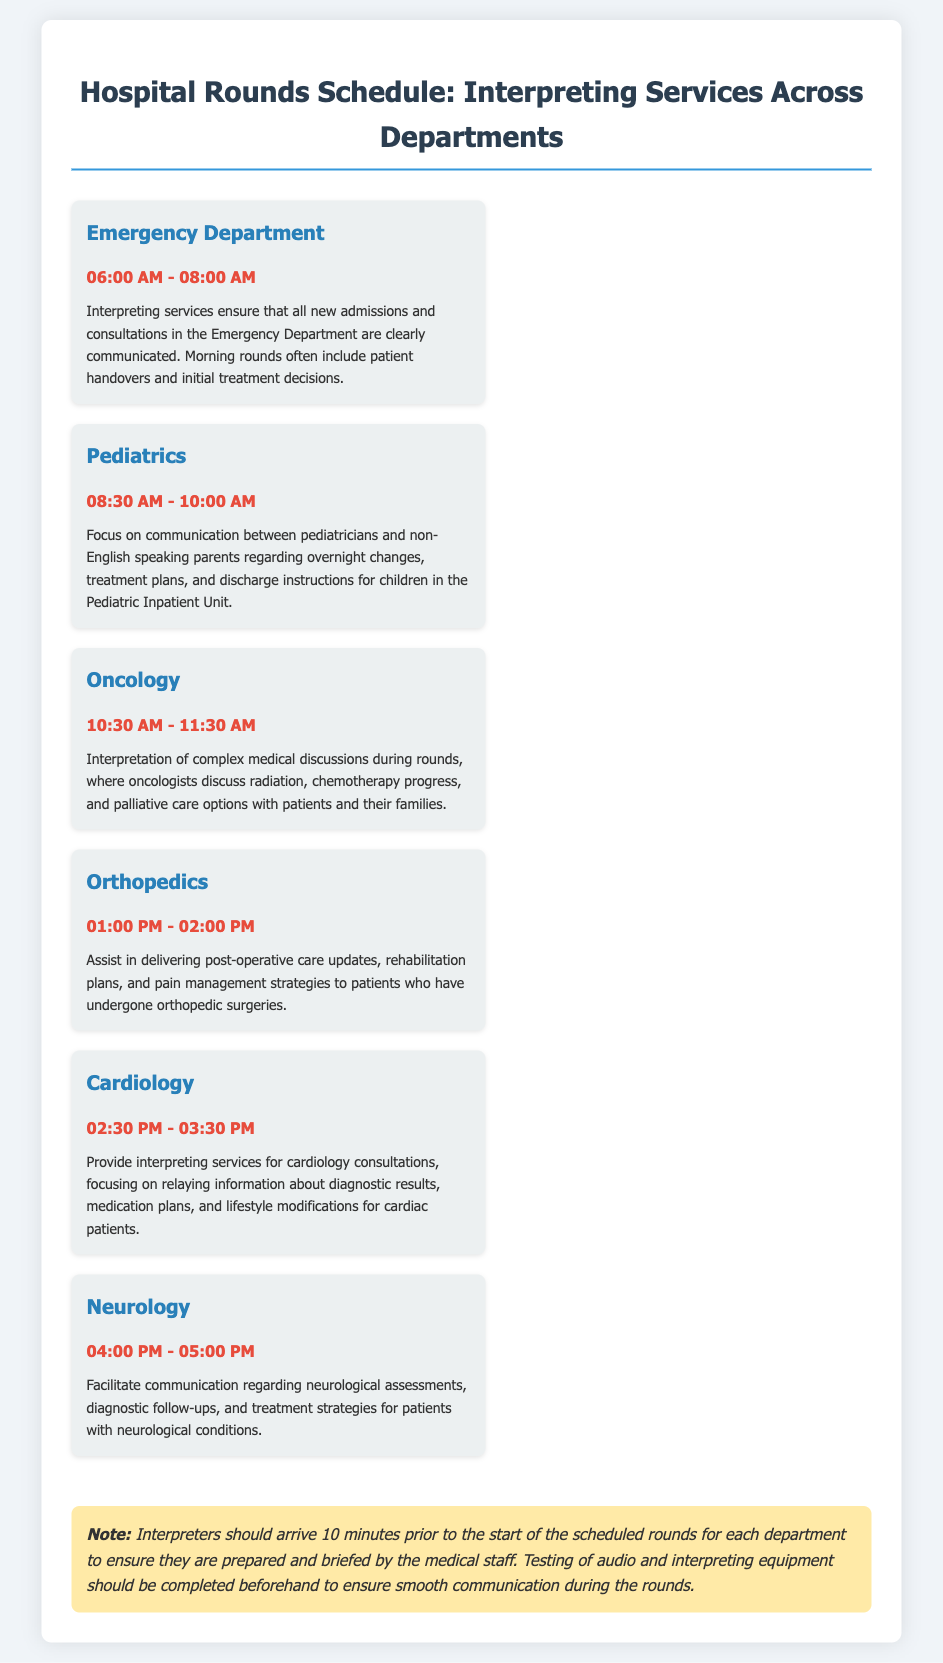What time does the Emergency Department schedule start? The schedule for the Emergency Department starts at 06:00 AM, according to the document.
Answer: 06:00 AM How long is the Pediatrics interpreting service scheduled for? The schedule indicates that interpreting services for Pediatrics are set for 1 hour and 30 minutes, from 08:30 AM to 10:00 AM.
Answer: 1 hour 30 minutes Which department has rounds at 10:30 AM? The document specifies that Oncology has scheduled rounds starting at 10:30 AM.
Answer: Oncology What is a focus area in the Cardiology department's interpreting services? The focus area for Cardiology interpreting services includes diagnostic results, medication plans, and lifestyle modifications.
Answer: Diagnostic results, medication plans, lifestyle modifications How many departments are included in the interpreting services schedule? The document lists a total of six departments providing interpreting services.
Answer: Six Why should interpreters arrive 10 minutes early? The document states interpreters should arrive early to prepare and be briefed by the medical staff.
Answer: To prepare and be briefed What time does the last department, Neurology, conclude? The Neurology interpreting service concludes at 05:00 PM, as specified in the timetable.
Answer: 05:00 PM What is a key task of interpreting services in the Oncology department? Key tasks in Oncology include the interpretation of complex medical discussions regarding treatment options.
Answer: Interpretation of complex medical discussions 